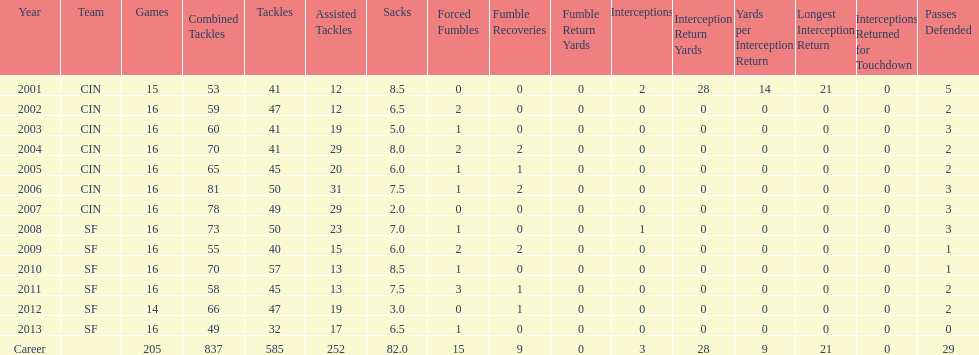What was the number of fumble recoveries for this player in 2004? 2. 